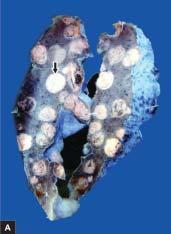what shows replacement of slaty-grey spongy parenchyma with multiple, firm, grey-white nodular masses, some having areas of haemorhages and necrosis?
Answer the question using a single word or phrase. Sectioned surface of the lung 